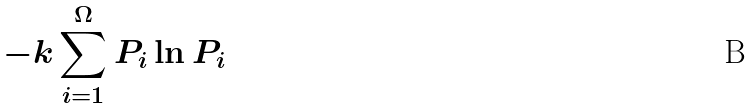<formula> <loc_0><loc_0><loc_500><loc_500>- k \sum _ { i = 1 } ^ { \Omega } P _ { i } \ln P _ { i }</formula> 